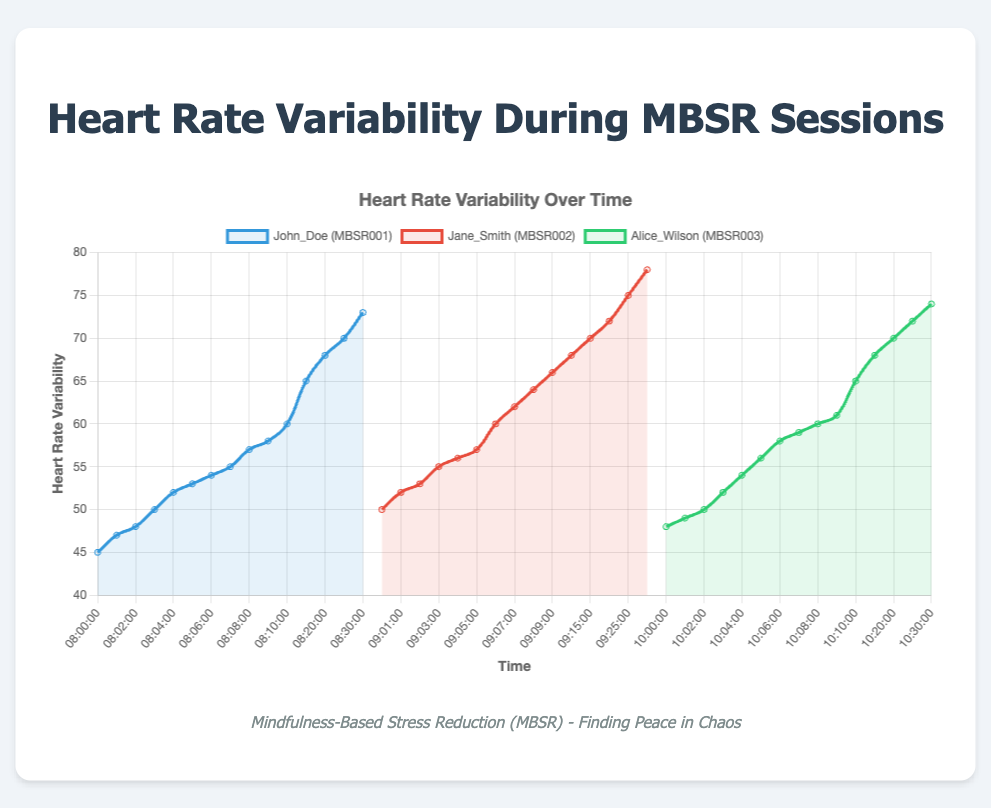What is the initial heart rate variability of John Doe? Refer to John Doe's line on the chart (blue line), the first data point at 08:00:00 displays the initial heart rate variability.
Answer: 45 Which client shows the highest heart rate variability at the end of their session? Compare the heart rate variability at the final time points for each client: John Doe (73), Jane Smith (78), Alice Wilson (74).
Answer: Jane Smith At what time does Alice Wilson's heart rate variability reach 65? Inspect Alice Wilson’s line on the chart (green line); find the point where the heart rate variability reaches 65.
Answer: 10:10 Which client shows the largest increase in heart rate variability during their session? Calculate the difference between the start and end heart rate variability for each client: John Doe (73-45=28), Jane Smith (78-50=28), Alice Wilson (74-48=26). John Doe and Jane Smith both show an increase of 28.
Answer: John Doe and Jane Smith What is the average heart rate variability of Jane Smith at the start, middle (09:15:00), and end of her session? Average of Jane Smith's heart rate variability values: start (50), middle (70), end (78). Average = (50+70+78)/3 = 66.
Answer: 66 Who has the highest heart rate variability at the 10-minute mark? Refer to the chart and compare 10-minute values for all: John Doe (60 at 08:10), Jane Smith (68 at 09:10), and Alice Wilson (65 at 10:10).
Answer: Jane Smith Which client's heart rate variability shows consistent upward trends throughout the session? Observe the slopes of lines for periods of steady increase: all lines partly upwards, but look closer for more consistent upward trend. John Doe (fairly consistent), Jane Smith (consistent), Alice Wilson (consistent).
Answer: All clients At the 20-minute mark, what is the difference in heart rate variability between John Doe and Jane Smith? Check their heart rate variability at 20 minutes: John Doe (68 at 08:20), Jane Smith (72 at 09:20). Difference = 72-68 = 4.
Answer: 4 What is the average heart rate variability for John Doe every five minutes for the first fifteen minutes of the session? Data points for John Doe: 45 (08:00), 53 (08:05), 65 (08:15). Average = (45 + 53 + 65)/3 = 54.33.
Answer: 54.33 